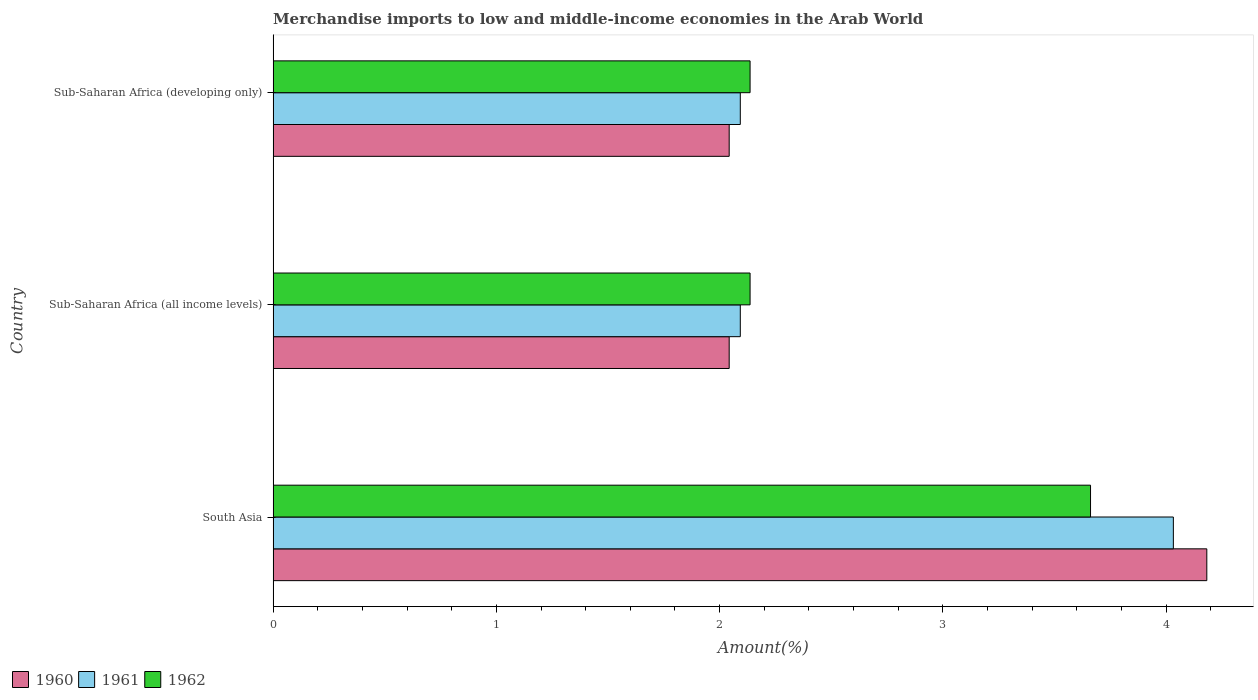How many different coloured bars are there?
Make the answer very short. 3. How many groups of bars are there?
Make the answer very short. 3. Are the number of bars per tick equal to the number of legend labels?
Your answer should be compact. Yes. Are the number of bars on each tick of the Y-axis equal?
Your answer should be compact. Yes. How many bars are there on the 1st tick from the top?
Keep it short and to the point. 3. How many bars are there on the 2nd tick from the bottom?
Your answer should be compact. 3. What is the label of the 1st group of bars from the top?
Your answer should be compact. Sub-Saharan Africa (developing only). What is the percentage of amount earned from merchandise imports in 1961 in South Asia?
Ensure brevity in your answer.  4.03. Across all countries, what is the maximum percentage of amount earned from merchandise imports in 1961?
Offer a terse response. 4.03. Across all countries, what is the minimum percentage of amount earned from merchandise imports in 1961?
Make the answer very short. 2.09. In which country was the percentage of amount earned from merchandise imports in 1962 maximum?
Make the answer very short. South Asia. In which country was the percentage of amount earned from merchandise imports in 1961 minimum?
Keep it short and to the point. Sub-Saharan Africa (all income levels). What is the total percentage of amount earned from merchandise imports in 1962 in the graph?
Your answer should be very brief. 7.93. What is the difference between the percentage of amount earned from merchandise imports in 1962 in South Asia and that in Sub-Saharan Africa (developing only)?
Your response must be concise. 1.53. What is the difference between the percentage of amount earned from merchandise imports in 1961 in Sub-Saharan Africa (developing only) and the percentage of amount earned from merchandise imports in 1960 in Sub-Saharan Africa (all income levels)?
Ensure brevity in your answer.  0.05. What is the average percentage of amount earned from merchandise imports in 1962 per country?
Ensure brevity in your answer.  2.64. What is the difference between the percentage of amount earned from merchandise imports in 1960 and percentage of amount earned from merchandise imports in 1961 in Sub-Saharan Africa (developing only)?
Make the answer very short. -0.05. In how many countries, is the percentage of amount earned from merchandise imports in 1960 greater than 3.6 %?
Keep it short and to the point. 1. What is the ratio of the percentage of amount earned from merchandise imports in 1960 in Sub-Saharan Africa (all income levels) to that in Sub-Saharan Africa (developing only)?
Your answer should be very brief. 1. Is the percentage of amount earned from merchandise imports in 1961 in South Asia less than that in Sub-Saharan Africa (developing only)?
Your answer should be compact. No. Is the difference between the percentage of amount earned from merchandise imports in 1960 in South Asia and Sub-Saharan Africa (all income levels) greater than the difference between the percentage of amount earned from merchandise imports in 1961 in South Asia and Sub-Saharan Africa (all income levels)?
Provide a succinct answer. Yes. What is the difference between the highest and the second highest percentage of amount earned from merchandise imports in 1961?
Your response must be concise. 1.94. What is the difference between the highest and the lowest percentage of amount earned from merchandise imports in 1960?
Ensure brevity in your answer.  2.14. Is the sum of the percentage of amount earned from merchandise imports in 1962 in Sub-Saharan Africa (all income levels) and Sub-Saharan Africa (developing only) greater than the maximum percentage of amount earned from merchandise imports in 1960 across all countries?
Provide a short and direct response. Yes. Does the graph contain grids?
Keep it short and to the point. No. What is the title of the graph?
Keep it short and to the point. Merchandise imports to low and middle-income economies in the Arab World. Does "1965" appear as one of the legend labels in the graph?
Your response must be concise. No. What is the label or title of the X-axis?
Ensure brevity in your answer.  Amount(%). What is the label or title of the Y-axis?
Your response must be concise. Country. What is the Amount(%) in 1960 in South Asia?
Give a very brief answer. 4.18. What is the Amount(%) in 1961 in South Asia?
Make the answer very short. 4.03. What is the Amount(%) of 1962 in South Asia?
Your answer should be very brief. 3.66. What is the Amount(%) of 1960 in Sub-Saharan Africa (all income levels)?
Make the answer very short. 2.04. What is the Amount(%) of 1961 in Sub-Saharan Africa (all income levels)?
Keep it short and to the point. 2.09. What is the Amount(%) in 1962 in Sub-Saharan Africa (all income levels)?
Your answer should be very brief. 2.14. What is the Amount(%) in 1960 in Sub-Saharan Africa (developing only)?
Make the answer very short. 2.04. What is the Amount(%) of 1961 in Sub-Saharan Africa (developing only)?
Make the answer very short. 2.09. What is the Amount(%) in 1962 in Sub-Saharan Africa (developing only)?
Your response must be concise. 2.14. Across all countries, what is the maximum Amount(%) in 1960?
Your answer should be very brief. 4.18. Across all countries, what is the maximum Amount(%) in 1961?
Ensure brevity in your answer.  4.03. Across all countries, what is the maximum Amount(%) of 1962?
Your response must be concise. 3.66. Across all countries, what is the minimum Amount(%) in 1960?
Provide a short and direct response. 2.04. Across all countries, what is the minimum Amount(%) in 1961?
Your answer should be compact. 2.09. Across all countries, what is the minimum Amount(%) of 1962?
Keep it short and to the point. 2.14. What is the total Amount(%) in 1960 in the graph?
Ensure brevity in your answer.  8.27. What is the total Amount(%) in 1961 in the graph?
Offer a very short reply. 8.22. What is the total Amount(%) in 1962 in the graph?
Offer a terse response. 7.93. What is the difference between the Amount(%) in 1960 in South Asia and that in Sub-Saharan Africa (all income levels)?
Your answer should be compact. 2.14. What is the difference between the Amount(%) of 1961 in South Asia and that in Sub-Saharan Africa (all income levels)?
Provide a short and direct response. 1.94. What is the difference between the Amount(%) in 1962 in South Asia and that in Sub-Saharan Africa (all income levels)?
Offer a terse response. 1.53. What is the difference between the Amount(%) of 1960 in South Asia and that in Sub-Saharan Africa (developing only)?
Keep it short and to the point. 2.14. What is the difference between the Amount(%) in 1961 in South Asia and that in Sub-Saharan Africa (developing only)?
Give a very brief answer. 1.94. What is the difference between the Amount(%) in 1962 in South Asia and that in Sub-Saharan Africa (developing only)?
Your response must be concise. 1.53. What is the difference between the Amount(%) of 1960 in Sub-Saharan Africa (all income levels) and that in Sub-Saharan Africa (developing only)?
Your response must be concise. 0. What is the difference between the Amount(%) in 1962 in Sub-Saharan Africa (all income levels) and that in Sub-Saharan Africa (developing only)?
Give a very brief answer. 0. What is the difference between the Amount(%) in 1960 in South Asia and the Amount(%) in 1961 in Sub-Saharan Africa (all income levels)?
Your response must be concise. 2.09. What is the difference between the Amount(%) in 1960 in South Asia and the Amount(%) in 1962 in Sub-Saharan Africa (all income levels)?
Offer a terse response. 2.05. What is the difference between the Amount(%) in 1961 in South Asia and the Amount(%) in 1962 in Sub-Saharan Africa (all income levels)?
Your answer should be compact. 1.9. What is the difference between the Amount(%) in 1960 in South Asia and the Amount(%) in 1961 in Sub-Saharan Africa (developing only)?
Ensure brevity in your answer.  2.09. What is the difference between the Amount(%) of 1960 in South Asia and the Amount(%) of 1962 in Sub-Saharan Africa (developing only)?
Ensure brevity in your answer.  2.05. What is the difference between the Amount(%) in 1961 in South Asia and the Amount(%) in 1962 in Sub-Saharan Africa (developing only)?
Make the answer very short. 1.9. What is the difference between the Amount(%) of 1960 in Sub-Saharan Africa (all income levels) and the Amount(%) of 1961 in Sub-Saharan Africa (developing only)?
Offer a very short reply. -0.05. What is the difference between the Amount(%) of 1960 in Sub-Saharan Africa (all income levels) and the Amount(%) of 1962 in Sub-Saharan Africa (developing only)?
Offer a very short reply. -0.09. What is the difference between the Amount(%) of 1961 in Sub-Saharan Africa (all income levels) and the Amount(%) of 1962 in Sub-Saharan Africa (developing only)?
Ensure brevity in your answer.  -0.04. What is the average Amount(%) of 1960 per country?
Your answer should be compact. 2.76. What is the average Amount(%) in 1961 per country?
Offer a terse response. 2.74. What is the average Amount(%) of 1962 per country?
Keep it short and to the point. 2.64. What is the difference between the Amount(%) in 1960 and Amount(%) in 1961 in South Asia?
Your answer should be very brief. 0.15. What is the difference between the Amount(%) in 1960 and Amount(%) in 1962 in South Asia?
Provide a succinct answer. 0.52. What is the difference between the Amount(%) of 1961 and Amount(%) of 1962 in South Asia?
Offer a terse response. 0.37. What is the difference between the Amount(%) of 1960 and Amount(%) of 1961 in Sub-Saharan Africa (all income levels)?
Make the answer very short. -0.05. What is the difference between the Amount(%) in 1960 and Amount(%) in 1962 in Sub-Saharan Africa (all income levels)?
Your answer should be compact. -0.09. What is the difference between the Amount(%) in 1961 and Amount(%) in 1962 in Sub-Saharan Africa (all income levels)?
Your answer should be very brief. -0.04. What is the difference between the Amount(%) in 1960 and Amount(%) in 1961 in Sub-Saharan Africa (developing only)?
Make the answer very short. -0.05. What is the difference between the Amount(%) in 1960 and Amount(%) in 1962 in Sub-Saharan Africa (developing only)?
Offer a terse response. -0.09. What is the difference between the Amount(%) of 1961 and Amount(%) of 1962 in Sub-Saharan Africa (developing only)?
Offer a very short reply. -0.04. What is the ratio of the Amount(%) in 1960 in South Asia to that in Sub-Saharan Africa (all income levels)?
Your answer should be compact. 2.05. What is the ratio of the Amount(%) in 1961 in South Asia to that in Sub-Saharan Africa (all income levels)?
Offer a very short reply. 1.93. What is the ratio of the Amount(%) of 1962 in South Asia to that in Sub-Saharan Africa (all income levels)?
Offer a very short reply. 1.71. What is the ratio of the Amount(%) of 1960 in South Asia to that in Sub-Saharan Africa (developing only)?
Your answer should be compact. 2.05. What is the ratio of the Amount(%) in 1961 in South Asia to that in Sub-Saharan Africa (developing only)?
Offer a terse response. 1.93. What is the ratio of the Amount(%) in 1962 in South Asia to that in Sub-Saharan Africa (developing only)?
Your response must be concise. 1.71. What is the difference between the highest and the second highest Amount(%) of 1960?
Your answer should be compact. 2.14. What is the difference between the highest and the second highest Amount(%) in 1961?
Provide a short and direct response. 1.94. What is the difference between the highest and the second highest Amount(%) of 1962?
Offer a very short reply. 1.53. What is the difference between the highest and the lowest Amount(%) in 1960?
Ensure brevity in your answer.  2.14. What is the difference between the highest and the lowest Amount(%) of 1961?
Keep it short and to the point. 1.94. What is the difference between the highest and the lowest Amount(%) in 1962?
Give a very brief answer. 1.53. 